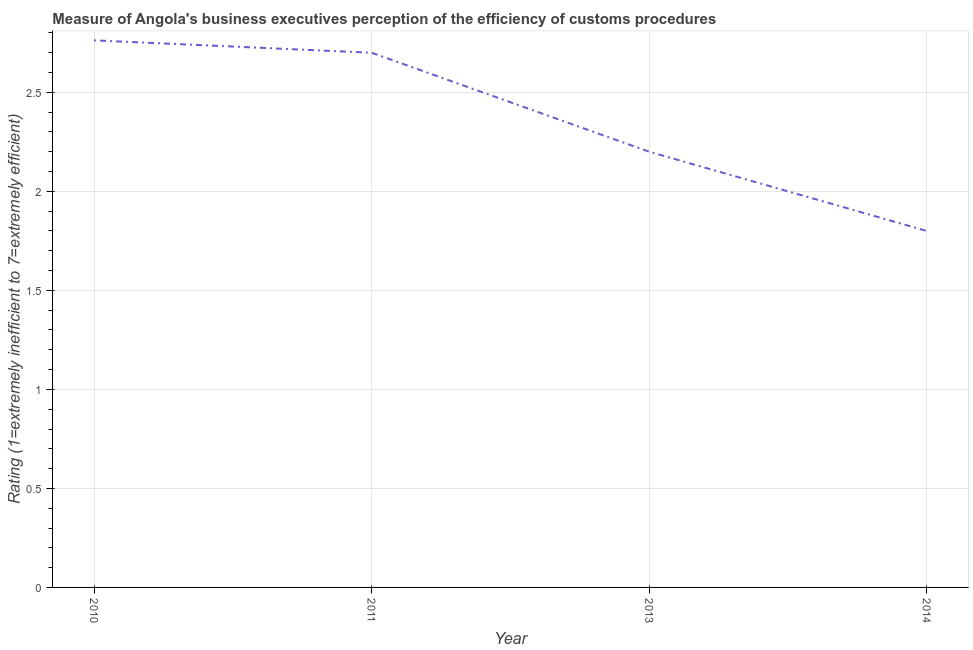Across all years, what is the maximum rating measuring burden of customs procedure?
Provide a short and direct response. 2.76. Across all years, what is the minimum rating measuring burden of customs procedure?
Provide a short and direct response. 1.8. What is the sum of the rating measuring burden of customs procedure?
Provide a succinct answer. 9.46. What is the difference between the rating measuring burden of customs procedure in 2011 and 2013?
Make the answer very short. 0.5. What is the average rating measuring burden of customs procedure per year?
Offer a very short reply. 2.37. What is the median rating measuring burden of customs procedure?
Provide a short and direct response. 2.45. In how many years, is the rating measuring burden of customs procedure greater than 1.8 ?
Keep it short and to the point. 3. Do a majority of the years between 2010 and 2011 (inclusive) have rating measuring burden of customs procedure greater than 1.6 ?
Make the answer very short. Yes. What is the ratio of the rating measuring burden of customs procedure in 2011 to that in 2013?
Your answer should be compact. 1.23. Is the rating measuring burden of customs procedure in 2010 less than that in 2011?
Give a very brief answer. No. What is the difference between the highest and the second highest rating measuring burden of customs procedure?
Your answer should be compact. 0.06. What is the difference between the highest and the lowest rating measuring burden of customs procedure?
Ensure brevity in your answer.  0.96. What is the difference between two consecutive major ticks on the Y-axis?
Your answer should be compact. 0.5. Are the values on the major ticks of Y-axis written in scientific E-notation?
Provide a succinct answer. No. What is the title of the graph?
Provide a succinct answer. Measure of Angola's business executives perception of the efficiency of customs procedures. What is the label or title of the X-axis?
Your answer should be very brief. Year. What is the label or title of the Y-axis?
Offer a very short reply. Rating (1=extremely inefficient to 7=extremely efficient). What is the Rating (1=extremely inefficient to 7=extremely efficient) of 2010?
Make the answer very short. 2.76. What is the Rating (1=extremely inefficient to 7=extremely efficient) of 2011?
Offer a terse response. 2.7. What is the difference between the Rating (1=extremely inefficient to 7=extremely efficient) in 2010 and 2011?
Provide a succinct answer. 0.06. What is the difference between the Rating (1=extremely inefficient to 7=extremely efficient) in 2010 and 2013?
Keep it short and to the point. 0.56. What is the difference between the Rating (1=extremely inefficient to 7=extremely efficient) in 2010 and 2014?
Your answer should be very brief. 0.96. What is the difference between the Rating (1=extremely inefficient to 7=extremely efficient) in 2011 and 2013?
Your answer should be very brief. 0.5. What is the difference between the Rating (1=extremely inefficient to 7=extremely efficient) in 2013 and 2014?
Give a very brief answer. 0.4. What is the ratio of the Rating (1=extremely inefficient to 7=extremely efficient) in 2010 to that in 2013?
Your response must be concise. 1.26. What is the ratio of the Rating (1=extremely inefficient to 7=extremely efficient) in 2010 to that in 2014?
Ensure brevity in your answer.  1.53. What is the ratio of the Rating (1=extremely inefficient to 7=extremely efficient) in 2011 to that in 2013?
Your answer should be compact. 1.23. What is the ratio of the Rating (1=extremely inefficient to 7=extremely efficient) in 2013 to that in 2014?
Make the answer very short. 1.22. 